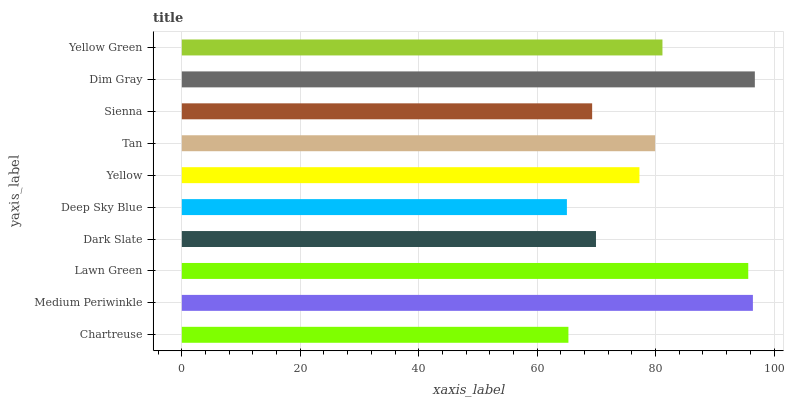Is Deep Sky Blue the minimum?
Answer yes or no. Yes. Is Dim Gray the maximum?
Answer yes or no. Yes. Is Medium Periwinkle the minimum?
Answer yes or no. No. Is Medium Periwinkle the maximum?
Answer yes or no. No. Is Medium Periwinkle greater than Chartreuse?
Answer yes or no. Yes. Is Chartreuse less than Medium Periwinkle?
Answer yes or no. Yes. Is Chartreuse greater than Medium Periwinkle?
Answer yes or no. No. Is Medium Periwinkle less than Chartreuse?
Answer yes or no. No. Is Tan the high median?
Answer yes or no. Yes. Is Yellow the low median?
Answer yes or no. Yes. Is Medium Periwinkle the high median?
Answer yes or no. No. Is Deep Sky Blue the low median?
Answer yes or no. No. 